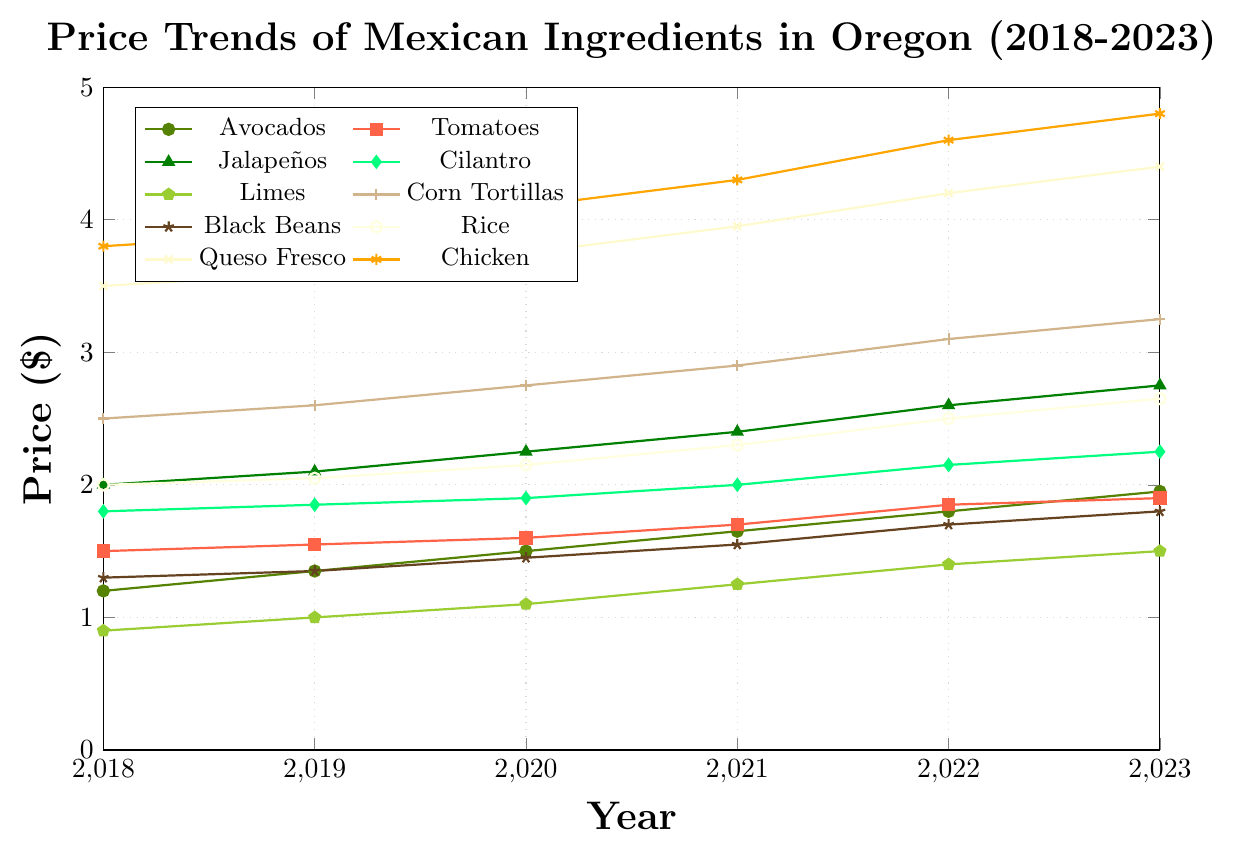Which ingredient had the highest price increase from 2018 to 2023? To determine which ingredient had the highest price increase from 2018 to 2023, calculate the price difference for each ingredient by subtracting the 2018 price from the 2023 price. The differences are: Avocados = 1.95 - 1.20 = 0.75, Tomatoes = 1.90 - 1.50 = 0.40, Jalapeños = 2.75 - 2.00 = 0.75, Cilantro = 2.25 - 1.80 = 0.45, Limes = 1.50 - 0.90 = 0.60, Corn Tortillas = 3.25 - 2.50 = 0.75, Black Beans = 1.80 - 1.30 = 0.50, Rice = 2.65 - 2.00 = 0.65, Queso Fresco = 4.40 - 3.50 = 0.90, Chicken = 4.80 - 3.80 = 1.00. Chicken has the highest price increase of 1.00.
Answer: Chicken Between which years did Avocados see the largest price increase? To find the years between which Avocados saw the largest price increase, compare the year-to-year price differences: 2019-2018 = 1.35 - 1.20 = 0.15, 2020-2019 = 1.50 - 1.35 = 0.15, 2021-2020 = 1.65 - 1.50 = 0.15, 2022-2021 = 1.80 - 1.65 = 0.15, 2023-2022 = 1.95 - 1.80 = 0.15. All yearly price increases are the same (0.15), so there is no single year pair with the largest increase; all increases are equal.
Answer: All yearly increases are equal What was the price difference between Queso Fresco and Chicken in 2023? To find the price difference between Queso Fresco and Chicken in 2023, subtract the price of Queso Fresco from the price of Chicken in 2023: 4.80 - 4.40 = 0.40.
Answer: 0.40 Which ingredient had the least price fluctuation from 2018 to 2023? To determine the ingredient with the least price fluctuation, calculate the total price change for each ingredient by subtracting the 2018 price from the 2023 price. The differences are: Avocados = 0.75, Tomatoes = 0.40, Jalapeños = 0.75, Cilantro = 0.45, Limes = 0.60, Corn Tortillas = 0.75, Black Beans = 0.50, Rice = 0.65, Queso Fresco = 0.90, Chicken = 1.00. Tomatoes had the least fluctuation at 0.40.
Answer: Tomatoes What is the average price of Black Beans from 2018 to 2023? To find the average price of Black Beans from 2018 to 2023, sum up their prices in each year and divide by the number of years: (1.30 + 1.35 + 1.45 + 1.55 + 1.70 + 1.80) / 6 = 9.15 / 6 = 1.525.
Answer: 1.525 Which ingredient was the most expensive in 2020? To find the most expensive ingredient in 2020, compare the prices of all ingredients in that year: Avocados = 1.50, Tomatoes = 1.60, Jalapeños = 2.25, Cilantro = 1.90, Limes = 1.10, Corn Tortillas = 2.75, Black Beans = 1.45, Rice = 2.15, Queso Fresco = 3.75, Chicken = 4.10. Chicken was the most expensive at 4.10.
Answer: Chicken In which year did Limes reach a price of 1.25? To determine the year when Limes reached a price of 1.25, look at the price list for Limes: 2018=0.90, 2019=1.00, 2020=1.10, 2021=1.25, 2022=1.40, 2023=1.50. Limes reached 1.25 in 2021.
Answer: 2021 